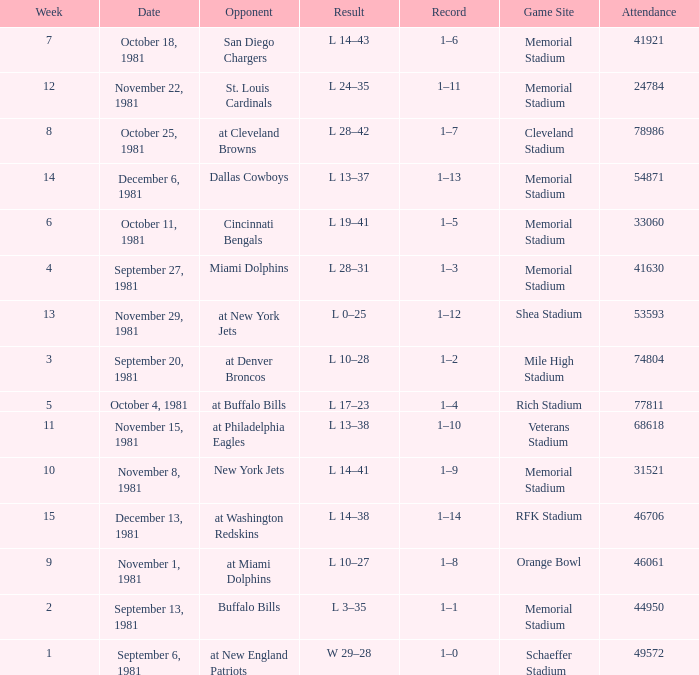When it is October 18, 1981 where is the game site? Memorial Stadium. 